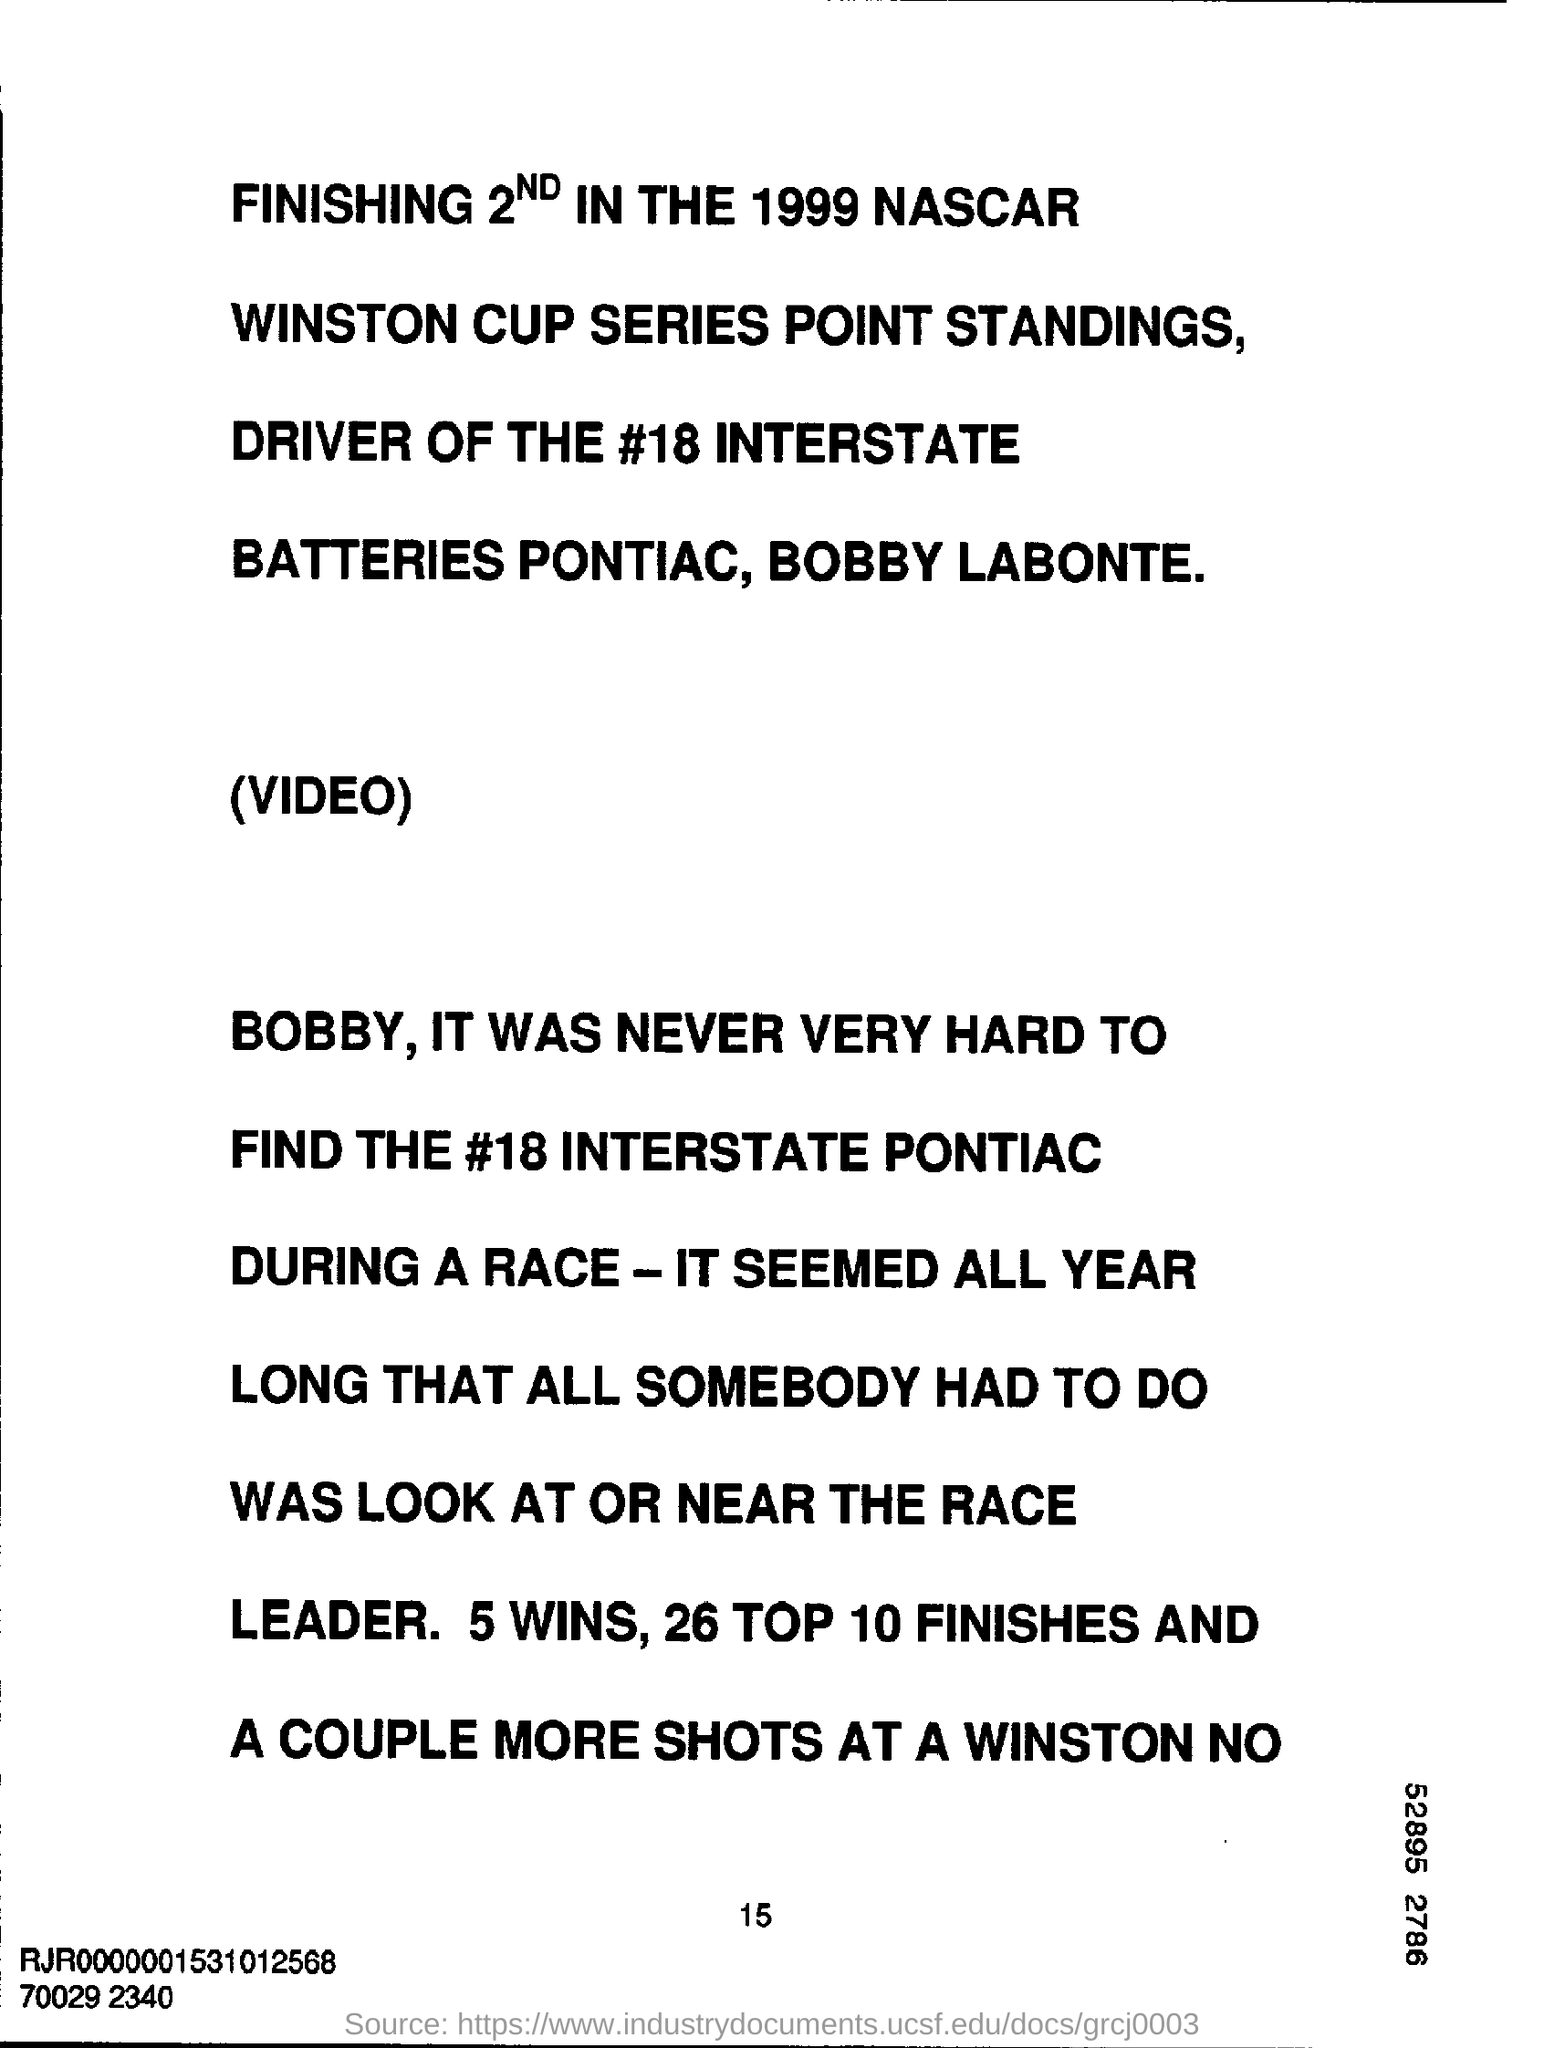Highlight a few significant elements in this photo. I declare that 5 wins are mentioned. The year mentioned is 1999. The hashtag reads the number 18. 